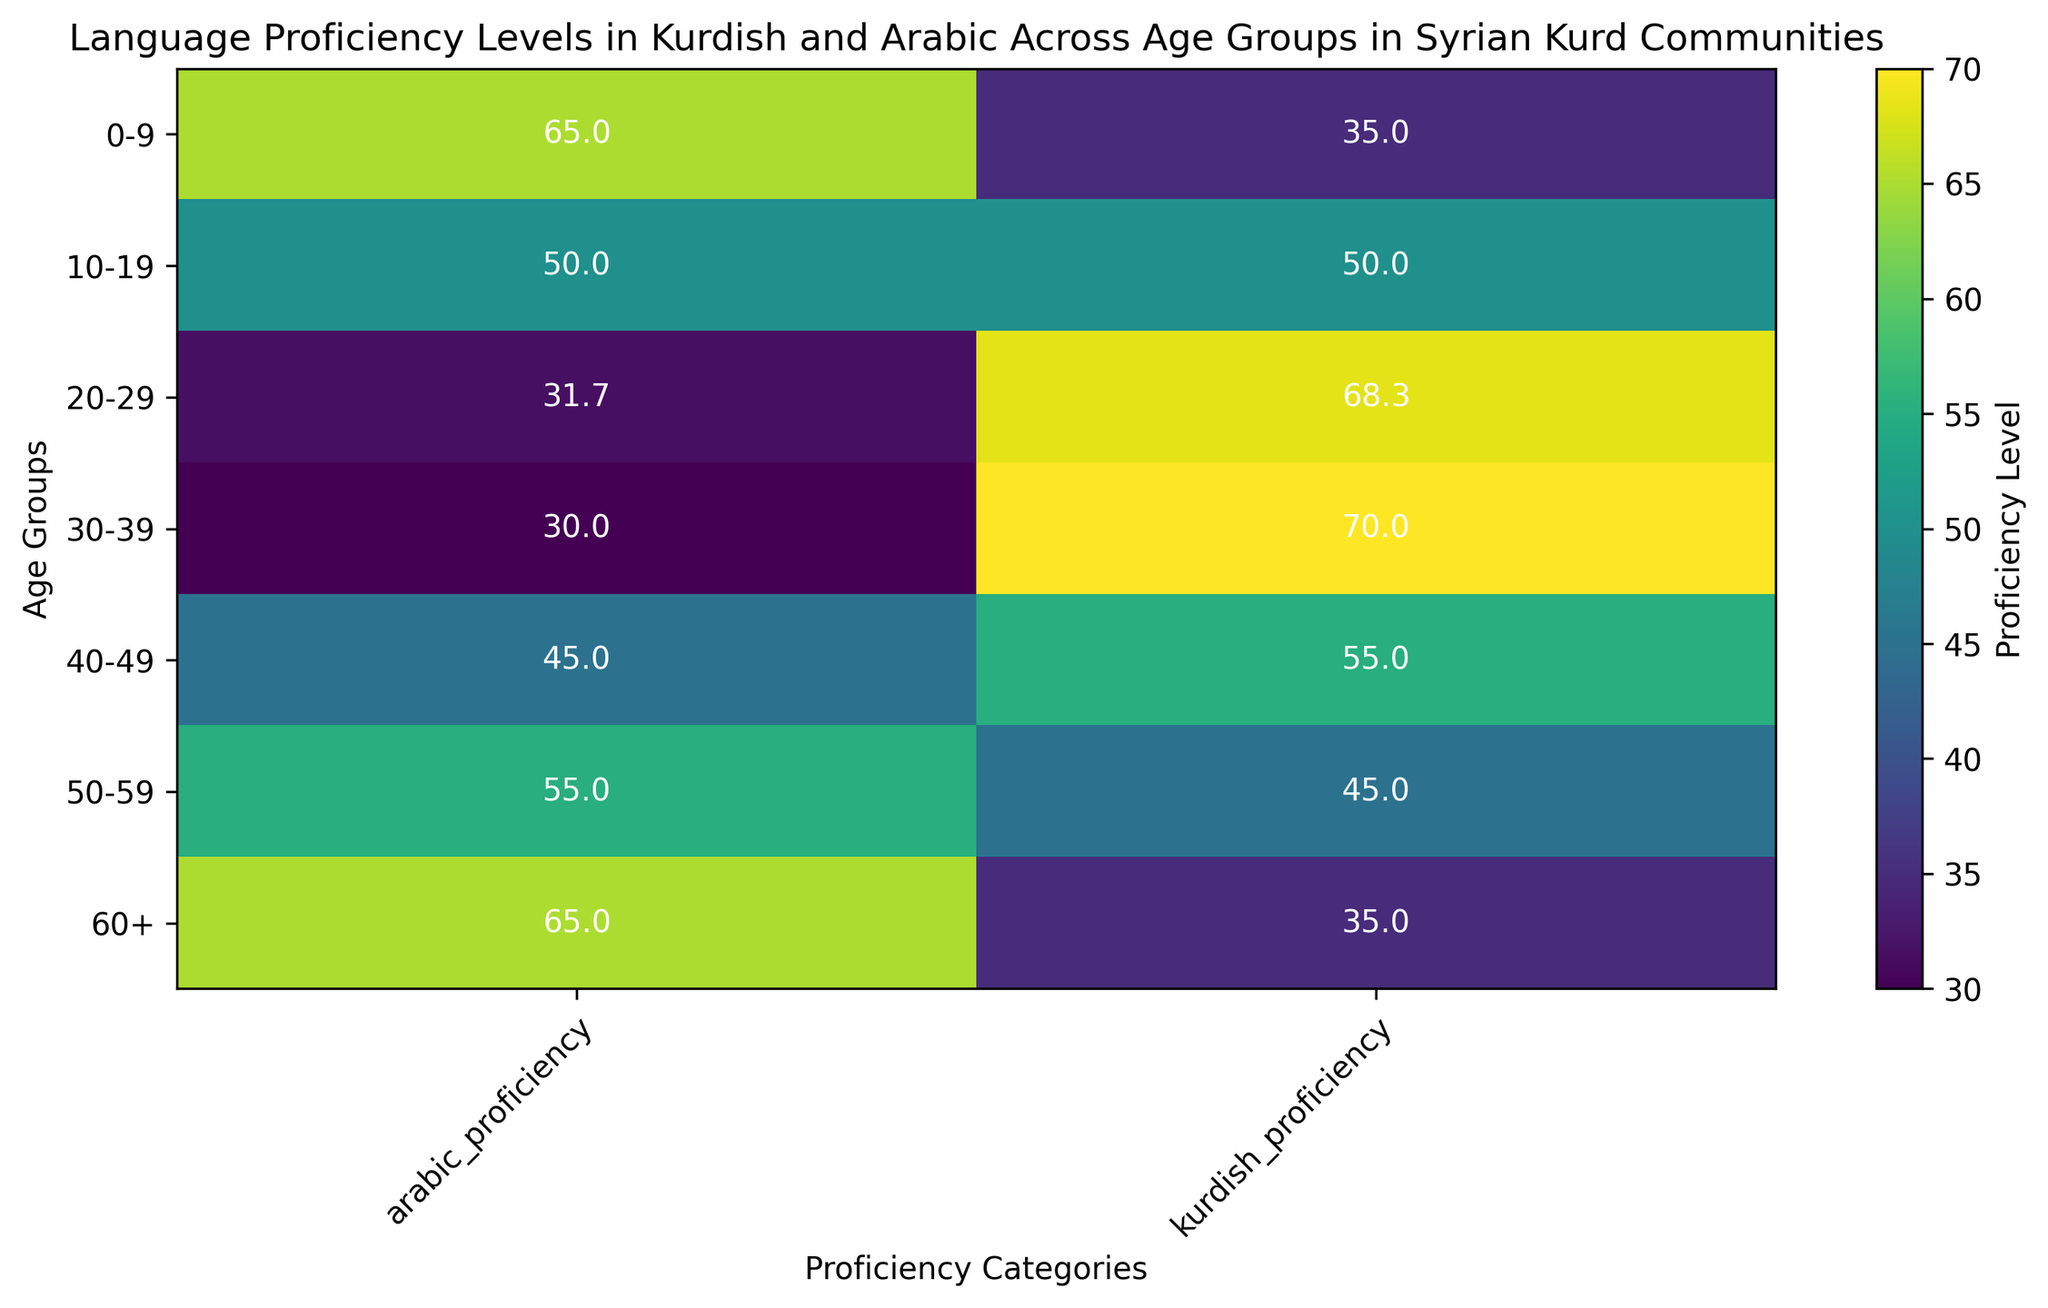what age group has the highest average proficiency in Kurdish? The figure shows average proficiency levels across different age groups. The 20-29 age group has the highest value for Kurdish proficiency, indicated by the lightest color and the highest number (68.3)
Answer: 20-29 What age group has the lowest average proficiency in Arabic? The figure shows proficiency levels across age groups. The 20-29 age group has the lowest Arabic proficiency, indicated by the darkest color and the lowest number (31.7)
Answer: 20-29 Compare the proficiency levels in Kurdish between the 30-39 and 40-49 age groups. Which one is higher? The figure shows mean proficiency levels for each age group. For Kurdish proficiency, 30-39 is higher (70.0) compared to 40-49 (55.0).
Answer: 30-39 What is the average Kurdish proficiency level for the 10-19 and 50-59 age groups combined? The average Kurdish proficiency for 10-19 is 50.0 and for 50-59 is 45.0. Calculating the combined average: (50.0 + 45.0) / 2 = 47.5
Answer: 47.5 What is the difference in Arabic proficiency between the 0-9 and 60+ age groups? The figure shows mean proficiency levels; Arabic proficiency for 0-9 is 65.0 and for 60+ is 65.0. The difference is 65.0 - 65.0 = 0
Answer: 0 Which age group has a nearly equal proficiency level in both Kurdish and Arabic? The age group 50-59 has nearly equal proficiency levels in Kurdish and Arabic, with both being 50.0 each.
Answer: 50-59 Compare the color intensity for the Kurdish proficiency of the 0-9 and 60+ age groups. Which is darker? The 0-9 age group represents a lighter color (35.0) than the 60+ age group (35.0) for Kurdish proficiency.
Answer: 0-9 Which proficiency level shows a more varied range of values across all age groups, Kurdish or Arabic? By observing the range and intensity variation in the colors, Kurdish proficiency has a wider range (30 to 75) compared to Arabic (25 to 70).
Answer: Kurdish What is the difference between highest and lowest average Arabic proficiency levels? The highest Arabic proficiency is 65.0 (0-9) and the lowest is 31.7 (20-29). The difference is 65.0 - 31.7 = 33.3
Answer: 33.3 What is the Kurdish proficiency level for the 40-49 age group? The figure indicates that the Kurdish proficiency level for the 40-49 age group is 55.0.
Answer: 55.0 